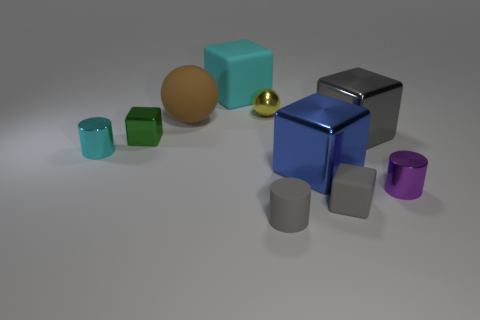How big is the yellow metal object?
Offer a terse response. Small. Is there a large cyan thing of the same shape as the blue metallic thing?
Keep it short and to the point. Yes. What number of things are tiny cyan objects or blocks right of the small green block?
Your response must be concise. 5. There is a tiny rubber object that is left of the blue metal object; what color is it?
Offer a very short reply. Gray. Do the sphere to the right of the cyan rubber thing and the sphere to the left of the cyan matte thing have the same size?
Your answer should be very brief. No. Is there a purple thing that has the same size as the brown ball?
Your response must be concise. No. There is a gray metallic block behind the tiny gray block; what number of tiny cubes are in front of it?
Give a very brief answer. 2. What is the cyan cylinder made of?
Offer a terse response. Metal. What number of large shiny things are in front of the big gray metal block?
Keep it short and to the point. 1. Is the large matte block the same color as the tiny metal block?
Make the answer very short. No. 